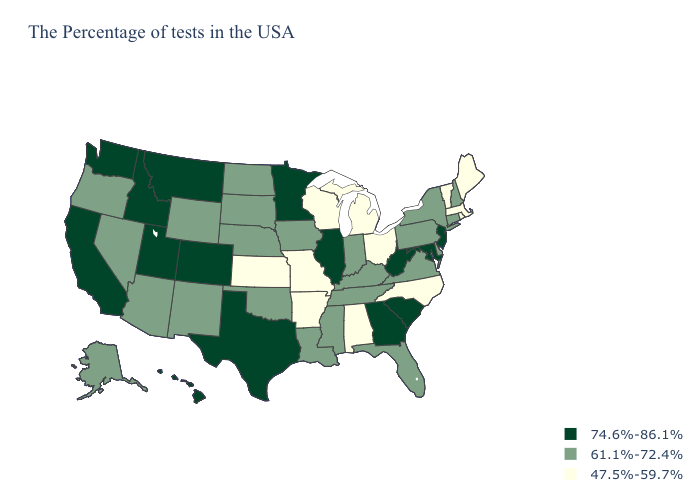What is the value of Michigan?
Quick response, please. 47.5%-59.7%. Name the states that have a value in the range 47.5%-59.7%?
Short answer required. Maine, Massachusetts, Rhode Island, Vermont, North Carolina, Ohio, Michigan, Alabama, Wisconsin, Missouri, Arkansas, Kansas. Does Alabama have the lowest value in the South?
Concise answer only. Yes. Among the states that border Wisconsin , which have the lowest value?
Quick response, please. Michigan. Which states have the lowest value in the West?
Give a very brief answer. Wyoming, New Mexico, Arizona, Nevada, Oregon, Alaska. Does Ohio have the same value as Texas?
Give a very brief answer. No. Does Nebraska have a higher value than Missouri?
Give a very brief answer. Yes. Name the states that have a value in the range 47.5%-59.7%?
Answer briefly. Maine, Massachusetts, Rhode Island, Vermont, North Carolina, Ohio, Michigan, Alabama, Wisconsin, Missouri, Arkansas, Kansas. Among the states that border Illinois , which have the lowest value?
Short answer required. Wisconsin, Missouri. Does Louisiana have the lowest value in the USA?
Concise answer only. No. What is the value of Montana?
Be succinct. 74.6%-86.1%. Does Oregon have the highest value in the USA?
Concise answer only. No. Does Kansas have the lowest value in the USA?
Write a very short answer. Yes. What is the value of Colorado?
Give a very brief answer. 74.6%-86.1%. What is the value of Mississippi?
Short answer required. 61.1%-72.4%. 